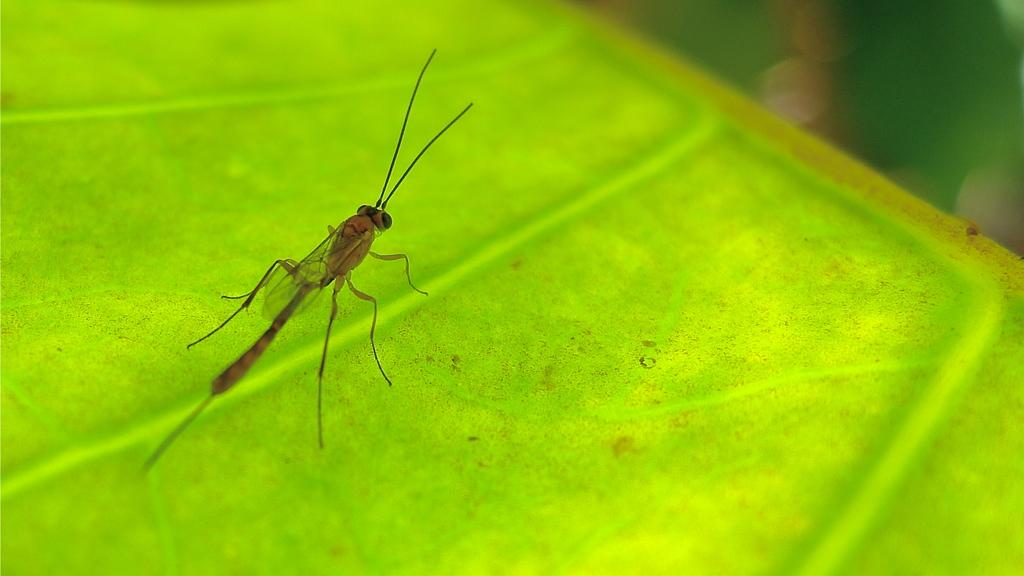What type of creature can be seen in the image? There is an insect in the image. What is the insect resting on? The insect is on a green surface. Can you describe the background of the image? The background of the image is blurred on the right side top. What song is the insect singing in the image? Insects do not sing songs, so there is no song being sung by the insect in the image. 